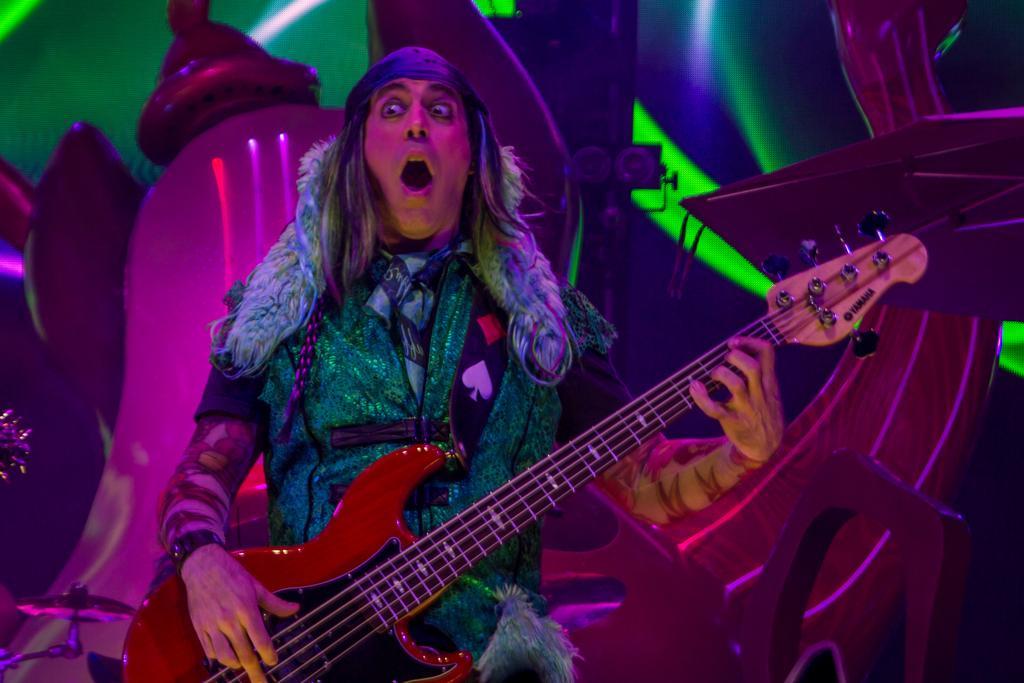In one or two sentences, can you explain what this image depicts? In this image there is a man standing and playing a guitar , and the back ground there is a cymbal stand. 